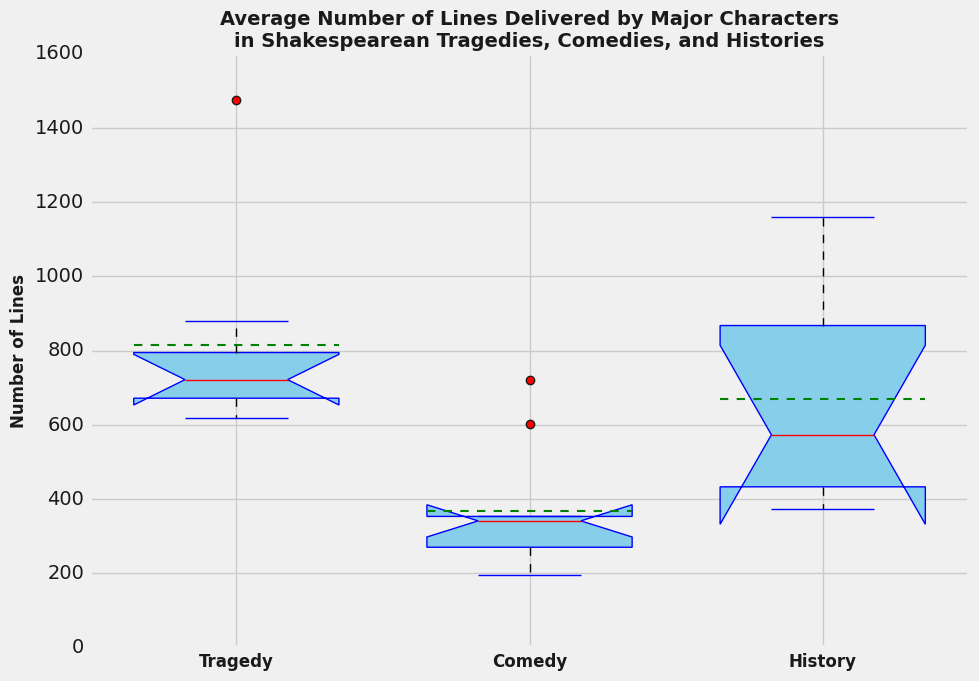What genre has the highest median number of lines delivered by major characters? Looking at the median values represented by the red lines within the boxes, the box plot indicates that Tragedy has the highest median compared to Comedy and History.
Answer: Tragedy Which genre shows the most variability in the number of lines delivered by major characters? Variability in a box plot is indicated by the length of the whiskers and the spread of the data points. History has the longest whiskers and the widest spread between the whiskers, indicating the most variability.
Answer: History Is the mean number of lines for Comedy higher or lower than the median number of lines for History? The mean is represented by a green dashed line. The mean number of lines for Comedy is below the median red line for History.
Answer: Lower What is the relationship between the interquartile ranges (IQR) of Tragedy and Comedy? The IQR, the distance between the first and third quartiles, is indicated by the length of the box. The IQR for Tragedy is clearly wider than that for Comedy, indicating greater interquartile range for Tragedy.
Answer: Tragedy is greater How does the lower whisker of Comedy compare to the lower whisker of History? The lower whisker extends to the smallest data point within 1.5 IQR of the lower quartile. The lower whisker for Comedy is higher than the lower whisker for History.
Answer: Higher Which genre has the smallest median number of lines delivered by major characters? By examining the red lines in each box, Comedy has the lowest median compared to Tragedy and History.
Answer: Comedy Are there any outliers in the data for Tragedy, and what do they indicate? Outliers in box plots are typically represented by red dots outside the whiskers. There are no outliers in the Tragedy data, indicating that all data points lie within 1.5 IQR of the quartiles.
Answer: No outliers Compare the position of the mean line to the median line in the Tragedy genre. What does this suggest? The mean line is above the median line in the Tragedy box, suggesting a right skew in the distribution of lines delivered by major characters in Tragedy.
Answer: Right skew 